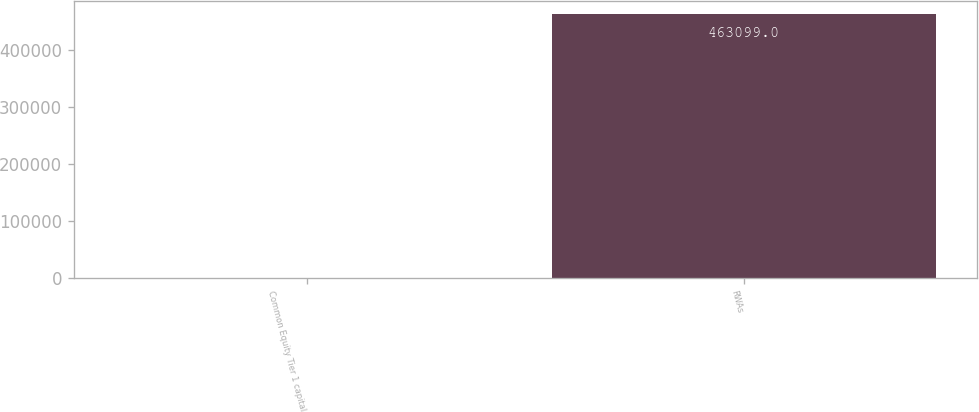Convert chart to OTSL. <chart><loc_0><loc_0><loc_500><loc_500><bar_chart><fcel>Common Equity Tier 1 capital<fcel>RWAs<nl><fcel>10.7<fcel>463099<nl></chart> 